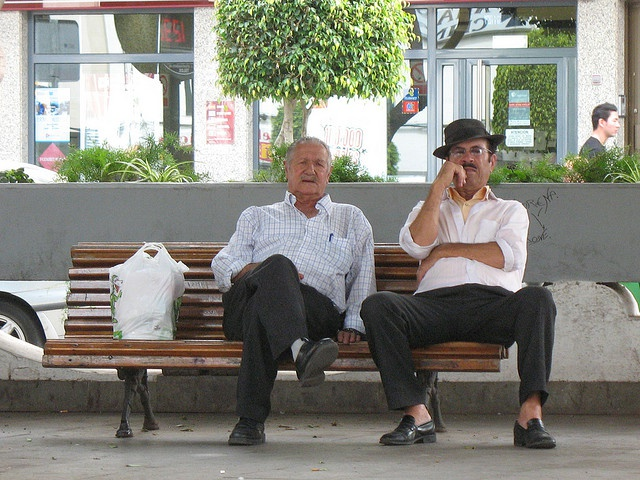Describe the objects in this image and their specific colors. I can see people in tan, black, lightgray, gray, and darkgray tones, people in tan, black, darkgray, and lightgray tones, bench in tan, black, maroon, and gray tones, backpack in tan, lightgray, darkgray, gray, and black tones, and car in tan, white, black, gray, and darkgray tones in this image. 